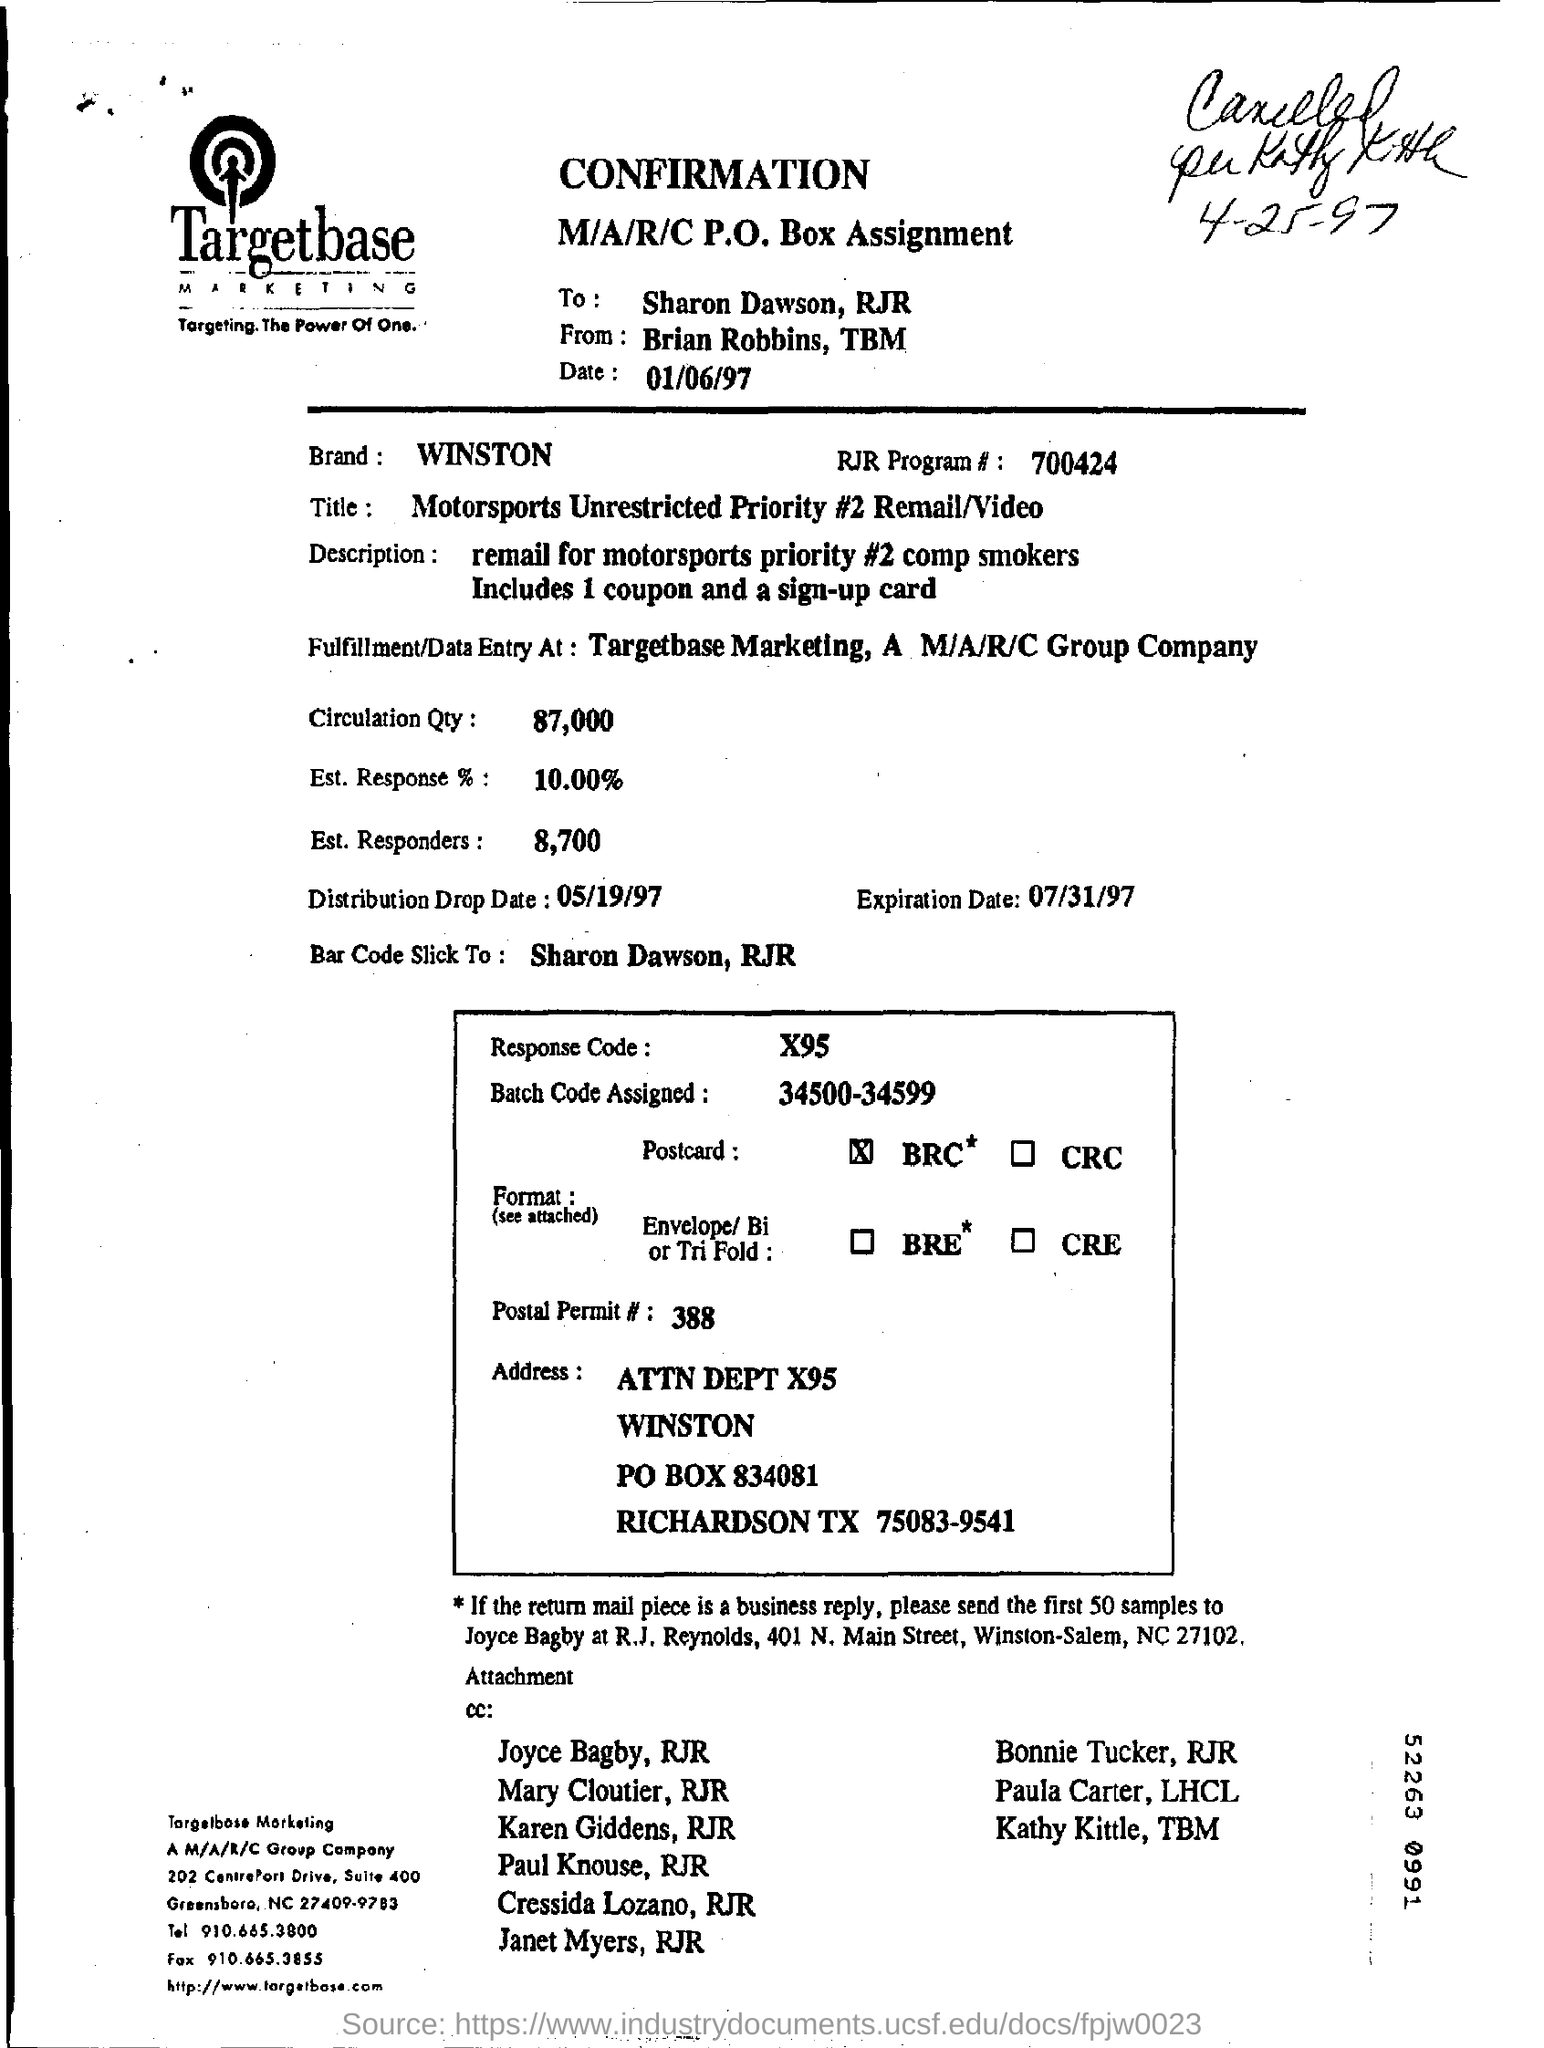Give some essential details in this illustration. The brand mentioned in the confirmation is WINSTON. The Motorsports Priority includes only one coupon. The person who sent the confirmation to Sharon Dawson is Brian Robbins. The recipient of the business reply samples is Joyce Bagby. 